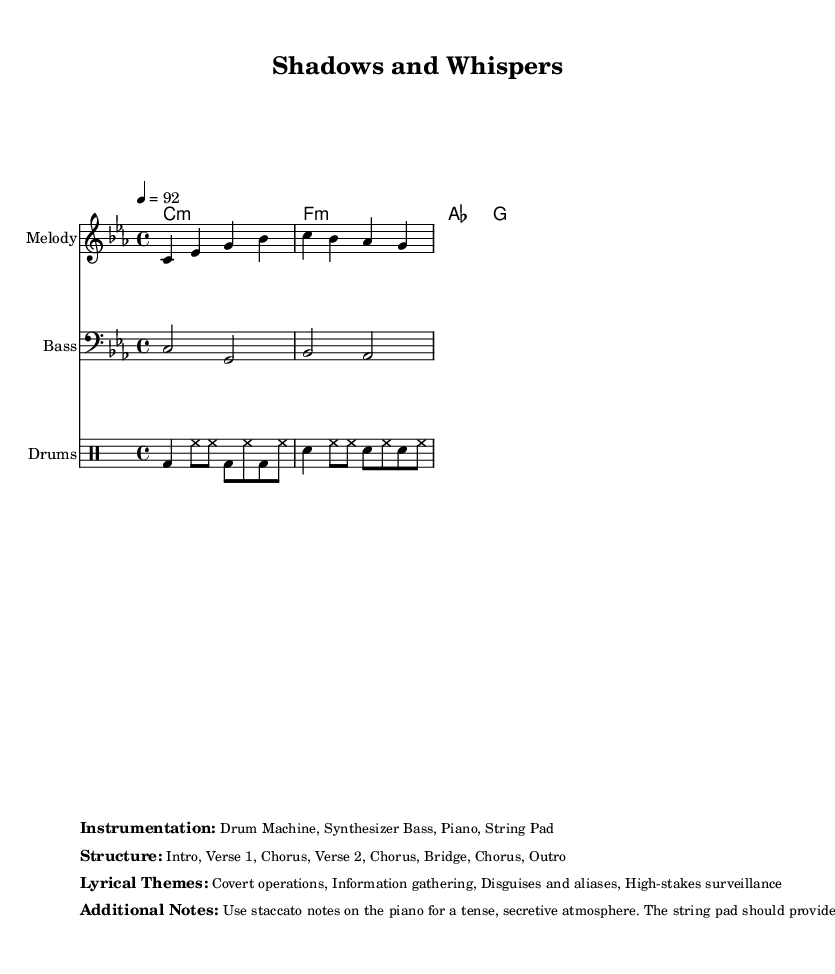What is the key signature of this music? The key signature is indicated in the global section as C minor, which contains three flats (B flat, E flat, and A flat).
Answer: C minor What is the time signature of this piece? The time signature is found in the global section as 4/4, indicating that there are four beats in a measure and the quarter note gets one beat.
Answer: 4/4 What is the tempo marking for the piece? The tempo marking is specified in the global section as 4 = 92, which indicates the speed of the music in beats per minute.
Answer: 92 How many verses does the structure include? The structure outlined in the markup specifies that there are two verses, which can be identified by the "Verse 1" and "Verse 2" labels.
Answer: 2 What lyrical themes are present in this music? The lyrical themes are listed in the markup and include covert operations, information gathering, disguises and aliases, and high-stakes surveillance.
Answer: Covert operations, Information gathering, Disguises and aliases, High-stakes surveillance How does the piano contribute to the atmosphere in this piece? The additional notes suggest using staccato notes on the piano to create a tense, secretive atmosphere, which adds to the suspense of the music.
Answer: Tense, secretive atmosphere What type of instruments are used in the instrumentation? The instrumentation is detailed in the markup section, mentioning a Drum Machine, Synthesizer Bass, Piano, and String Pad.
Answer: Drum Machine, Synthesizer Bass, Piano, String Pad 